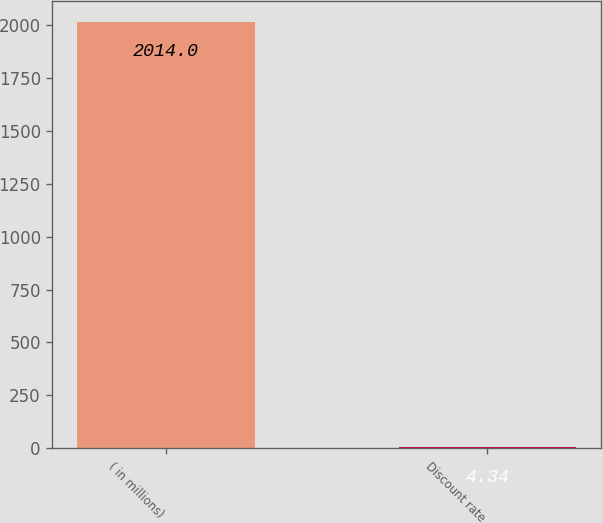<chart> <loc_0><loc_0><loc_500><loc_500><bar_chart><fcel>( in millions)<fcel>Discount rate<nl><fcel>2014<fcel>4.34<nl></chart> 